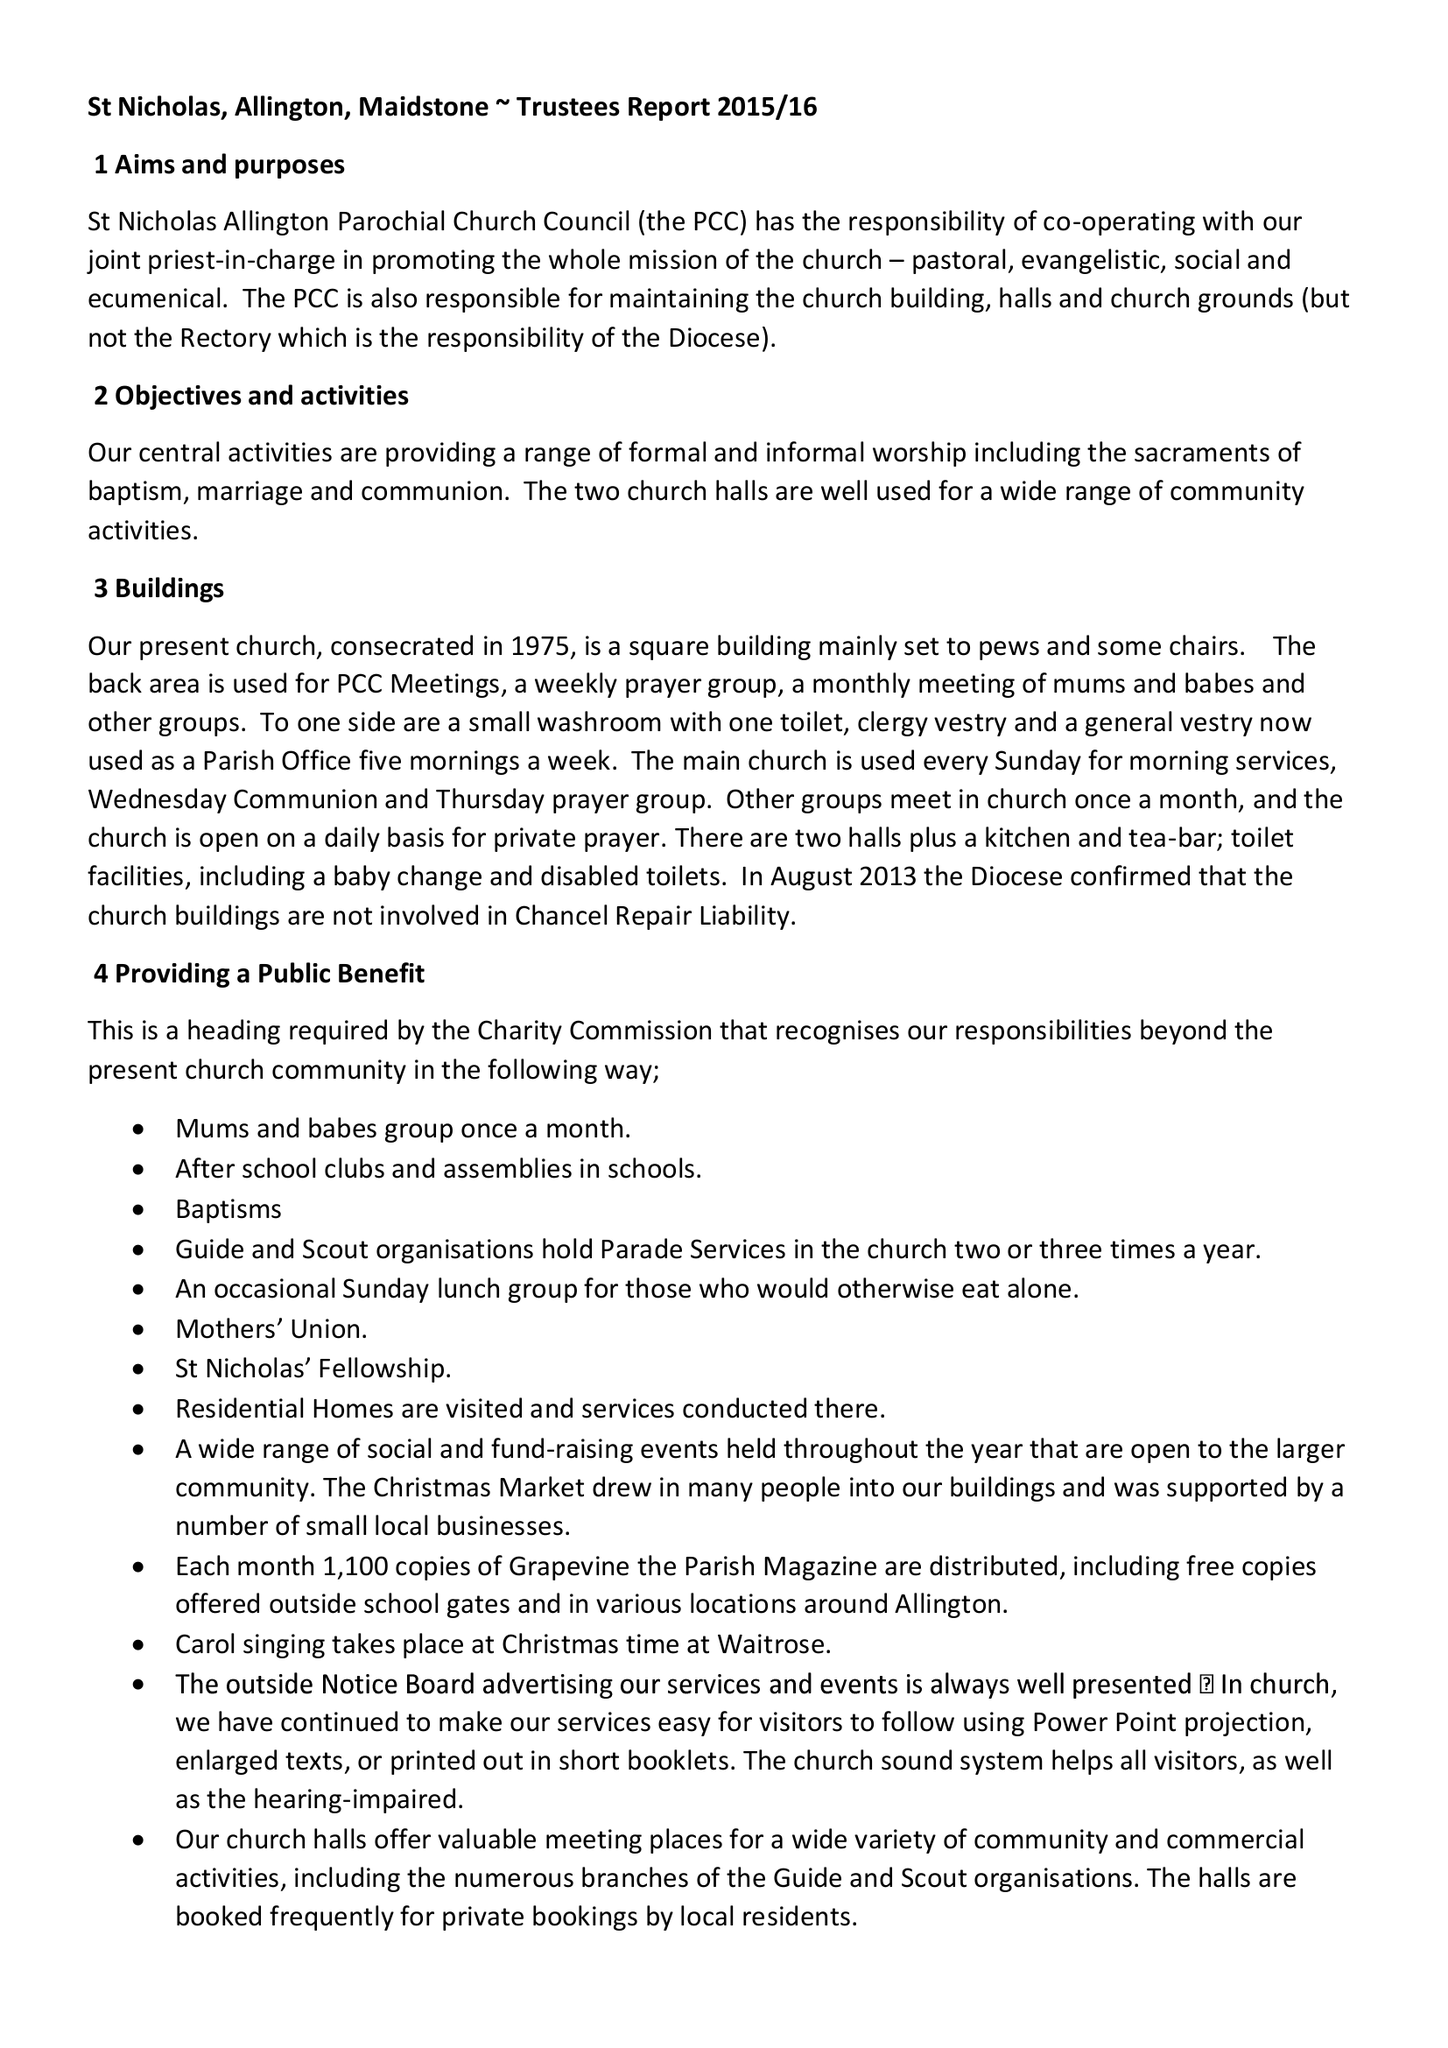What is the value for the address__street_line?
Answer the question using a single word or phrase. POPLAR GROVE 